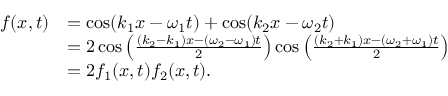<formula> <loc_0><loc_0><loc_500><loc_500>{ \begin{array} { r l } { f ( x , t ) } & { = \cos ( k _ { 1 } x - \omega _ { 1 } t ) + \cos ( k _ { 2 } x - \omega _ { 2 } t ) } \\ & { = 2 \cos \left ( { \frac { ( k _ { 2 } - k _ { 1 } ) x - ( \omega _ { 2 } - \omega _ { 1 } ) t } { 2 } } \right ) \cos \left ( { \frac { ( k _ { 2 } + k _ { 1 } ) x - ( \omega _ { 2 } + \omega _ { 1 } ) t } { 2 } } \right ) } \\ & { = 2 f _ { 1 } ( x , t ) f _ { 2 } ( x , t ) . } \end{array} }</formula> 